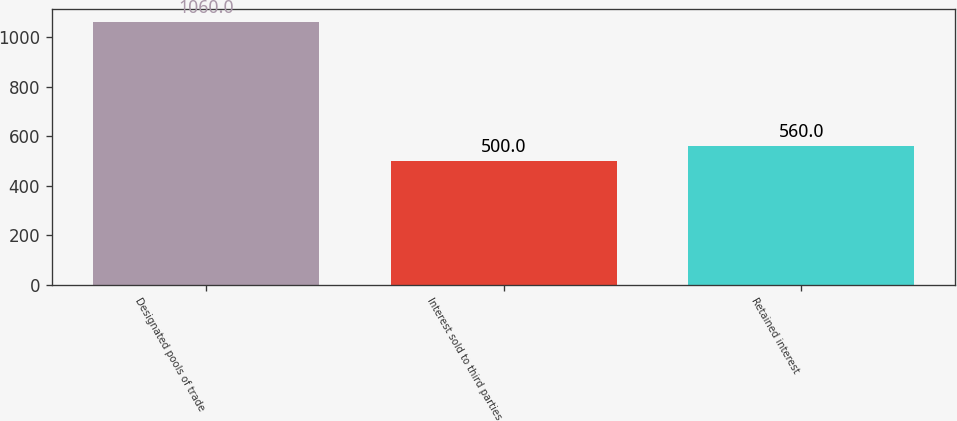<chart> <loc_0><loc_0><loc_500><loc_500><bar_chart><fcel>Designated pools of trade<fcel>Interest sold to third parties<fcel>Retained interest<nl><fcel>1060<fcel>500<fcel>560<nl></chart> 